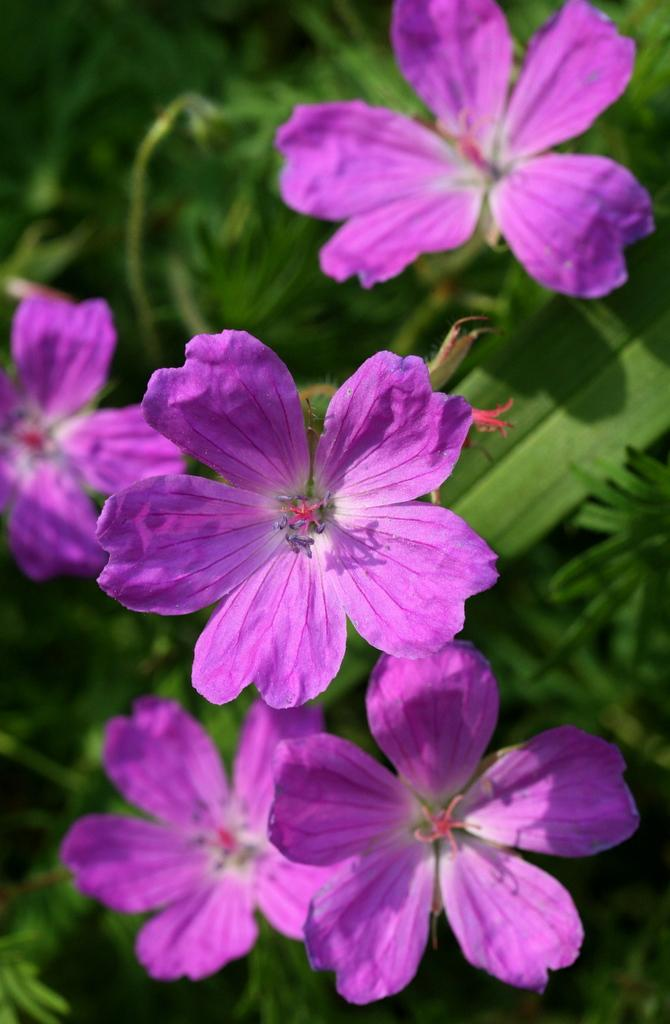What is the main subject of the image? The main subject of the image is a close-up of flowers. What color are the flowers in the image? The flowers are purple in color. What type of plant do the flowers belong to? The flowers belong to a plant. What type of badge can be seen on the flowers in the image? There is no badge present on the flowers in the image. How does the clam contribute to the growth of the flowers in the image? There is no clam present in the image, so it cannot contribute to the growth of the flowers. 